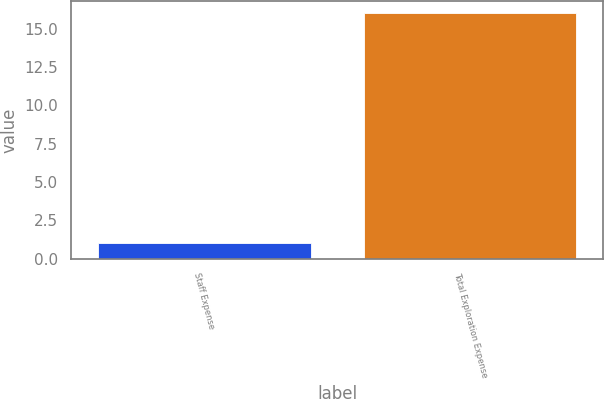Convert chart. <chart><loc_0><loc_0><loc_500><loc_500><bar_chart><fcel>Staff Expense<fcel>Total Exploration Expense<nl><fcel>1<fcel>16<nl></chart> 